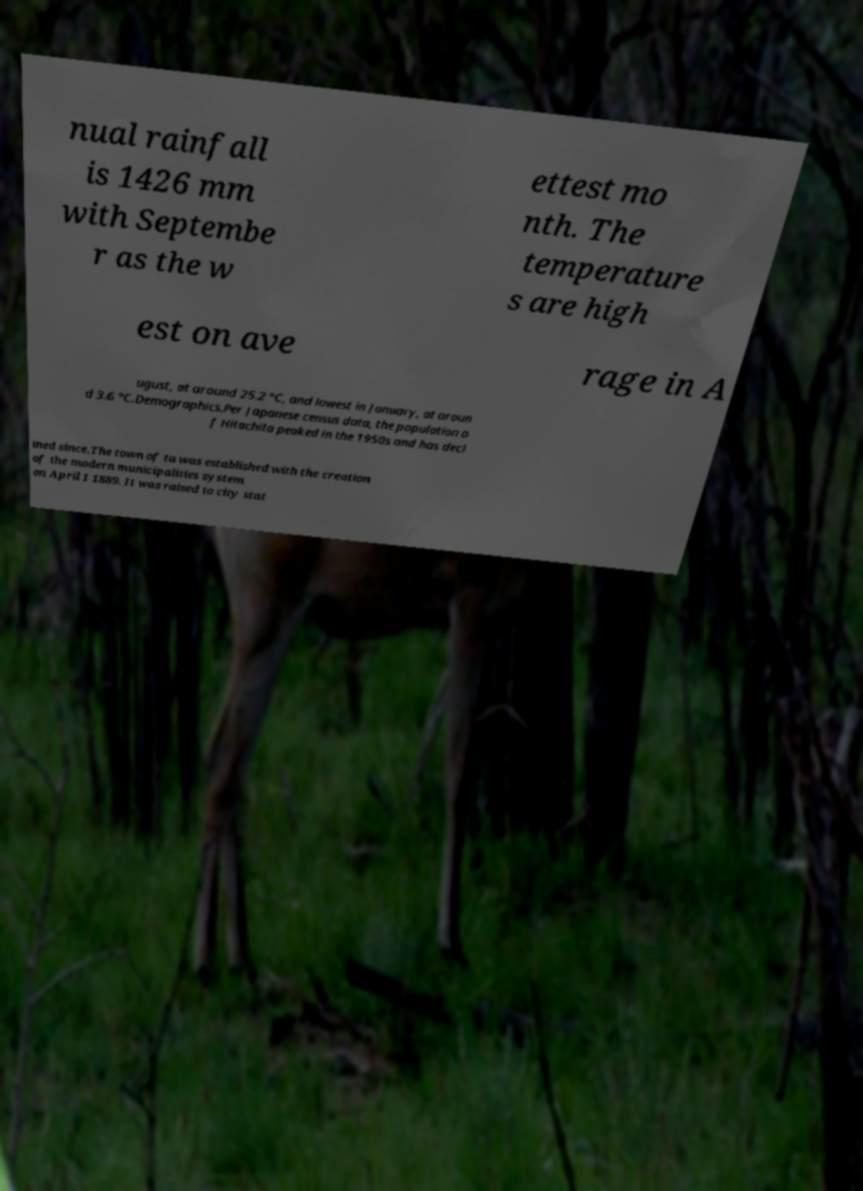Can you accurately transcribe the text from the provided image for me? nual rainfall is 1426 mm with Septembe r as the w ettest mo nth. The temperature s are high est on ave rage in A ugust, at around 25.2 °C, and lowest in January, at aroun d 3.6 °C.Demographics.Per Japanese census data, the population o f Hitachita peaked in the 1950s and has decl ined since.The town of ta was established with the creation of the modern municipalities system on April 1 1889. It was raised to city stat 